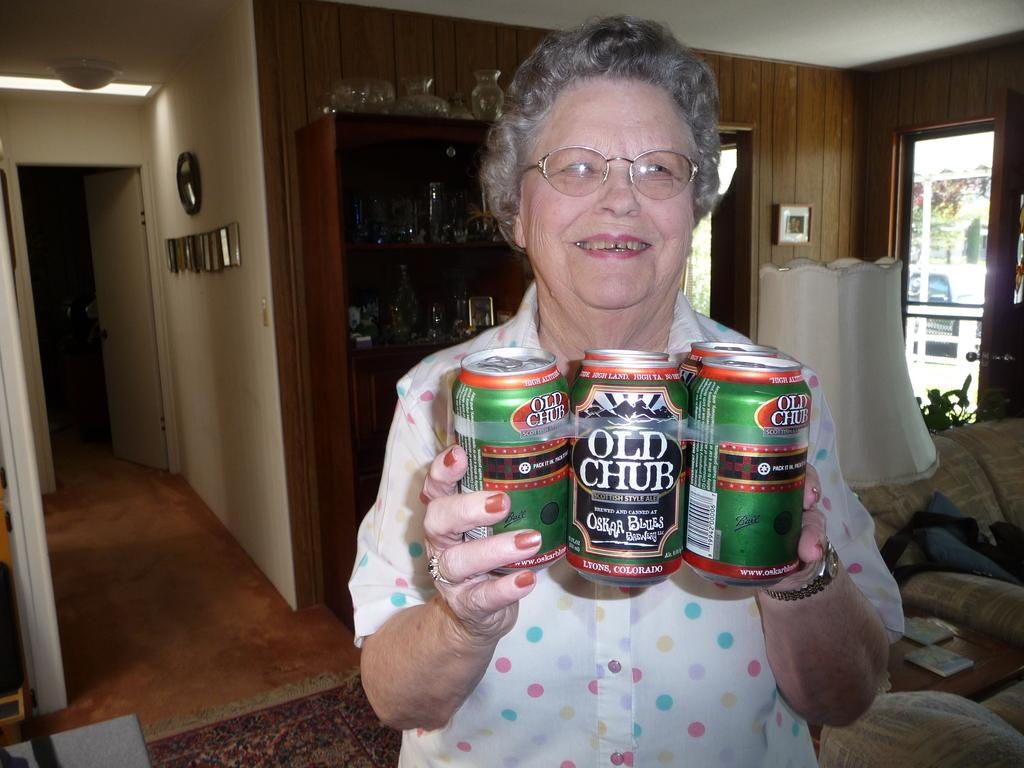What is the person holding in the image? The person is holding tins in the image. What can be seen in the background of the image? There is a couch, a lamp, a book on a table, a cupboard, doors, and frames attached to the wall in the background of the image. What type of shop can be seen in the background of the image? There is no shop present in the image; it is a person holding tins with various items in the background. Is there a battle taking place in the image? No, there is no battle depicted in the image. 